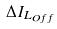<formula> <loc_0><loc_0><loc_500><loc_500>\Delta I _ { L _ { O f f } }</formula> 